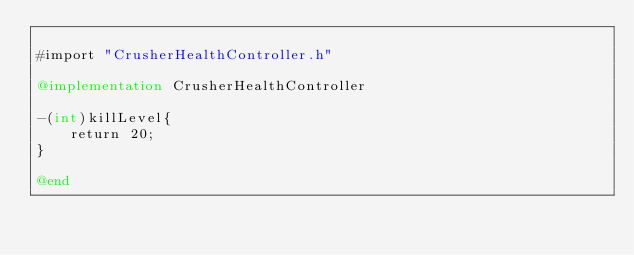Convert code to text. <code><loc_0><loc_0><loc_500><loc_500><_ObjectiveC_>
#import "CrusherHealthController.h"

@implementation CrusherHealthController

-(int)killLevel{
    return 20;
}

@end
</code> 